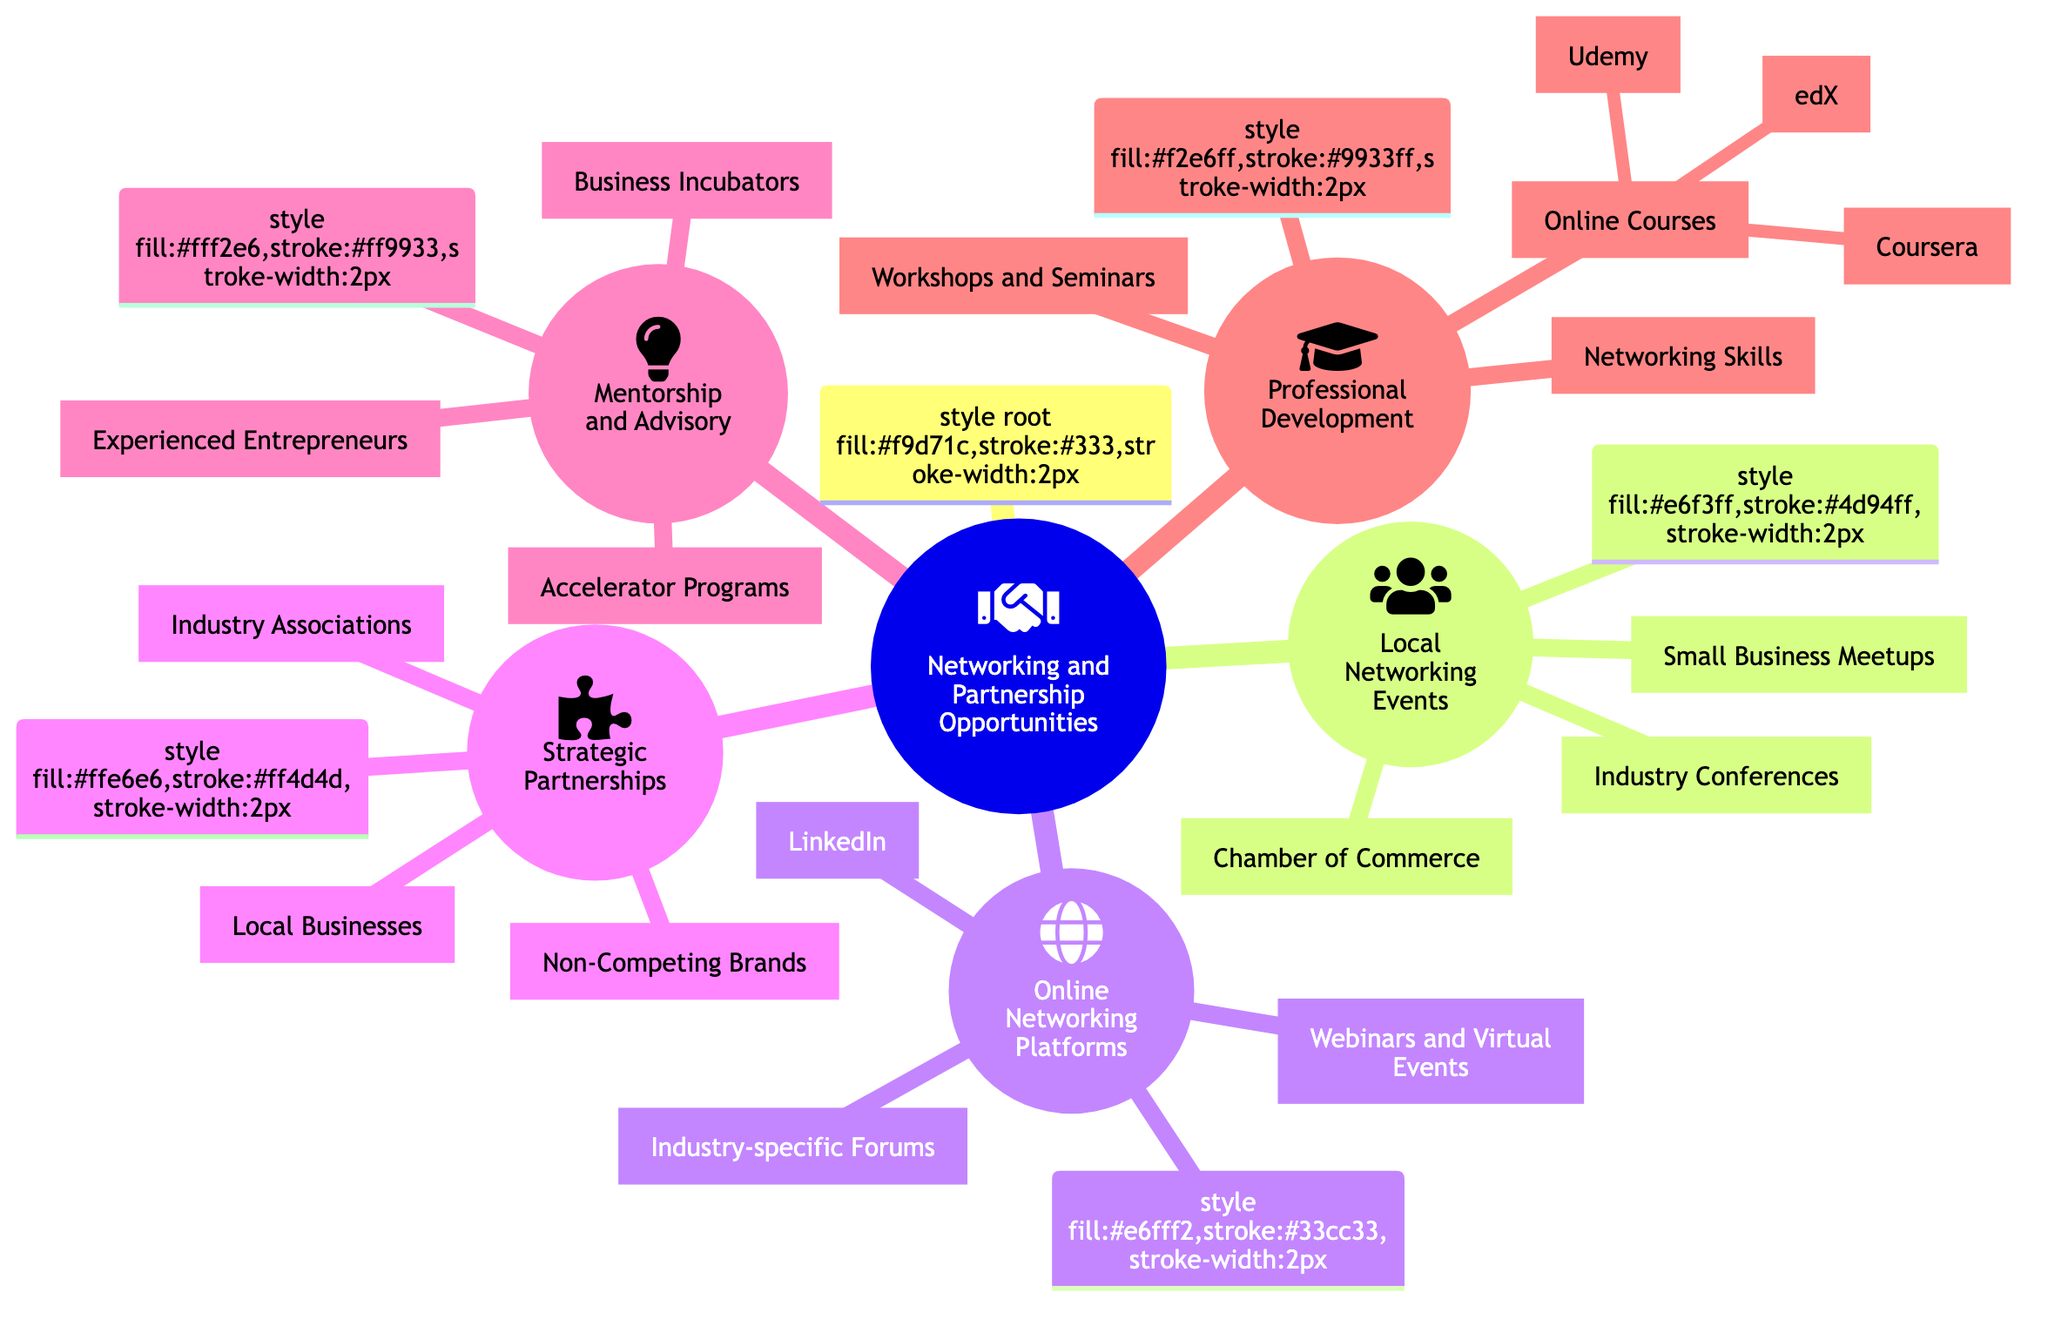What are the categories of networking opportunities? The diagram shows five main categories: Local Networking Events, Online Networking Platforms, Strategic Partnerships, Mentorship and Advisory, and Professional Development. Each category represents different ways to expand business reach.
Answer: Local Networking Events, Online Networking Platforms, Strategic Partnerships, Mentorship and Advisory, Professional Development How many local networking events are listed? Under the "Local Networking Events" category in the diagram, there are three specific events: Chamber of Commerce, Small Business Meetups, and Industry Conferences. This gives a total of three local networking events.
Answer: 3 Which online platform is included for networking? The diagram indicates that LinkedIn is one of the online networking platforms listed under "Online Networking Platforms." This implies that LinkedIn is emphasized as a key platform for networking.
Answer: LinkedIn What type of organizations fall under strategic partnerships? The "Strategic Partnerships" section includes three types of organizations: Local Businesses, Non-Competing Brands, and Industry Associations. This indicates the various collaboration opportunities.
Answer: Local Businesses, Non-Competing Brands, Industry Associations What is the purpose of mentorship and advisory? The "Mentorship and Advisory" section of the diagram highlights how these resources can guide business growth through programs like Business Incubators, Accelerator Programs, and support from Experienced Entrepreneurs. This indicates a focus on gaining insights and assistance.
Answer: Business Incubators, Accelerator Programs, Experienced Entrepreneurs How many online courses are listed under professional development? In the Professional Development section, there are three specific online courses mentioned: Coursera, Udemy, and edX. These indicate the platforms available for online learning.
Answer: 3 What is the relationship between local businesses and strategic partnerships? The diagram illustrates that Local Businesses are a specific type of organization that can form Strategic Partnerships. This relationship emphasizes collaboration between local enterprises to strengthen business reach.
Answer: Local Businesses are part of Strategic Partnerships Which category includes workshops and seminars? The "Professional Development" category encompasses Workshops and Seminars as methods for enhancing skills and business knowledge. This shows the significance of continual learning in business growth.
Answer: Professional Development What is the icon representing the main topic of the diagram? The main topic "Networking and Partnership Opportunities" is represented by the handshake icon, which symbolizes collaboration and connection. This is a visual cue to the viewers about the diagram's central theme.
Answer: Handshake icon 